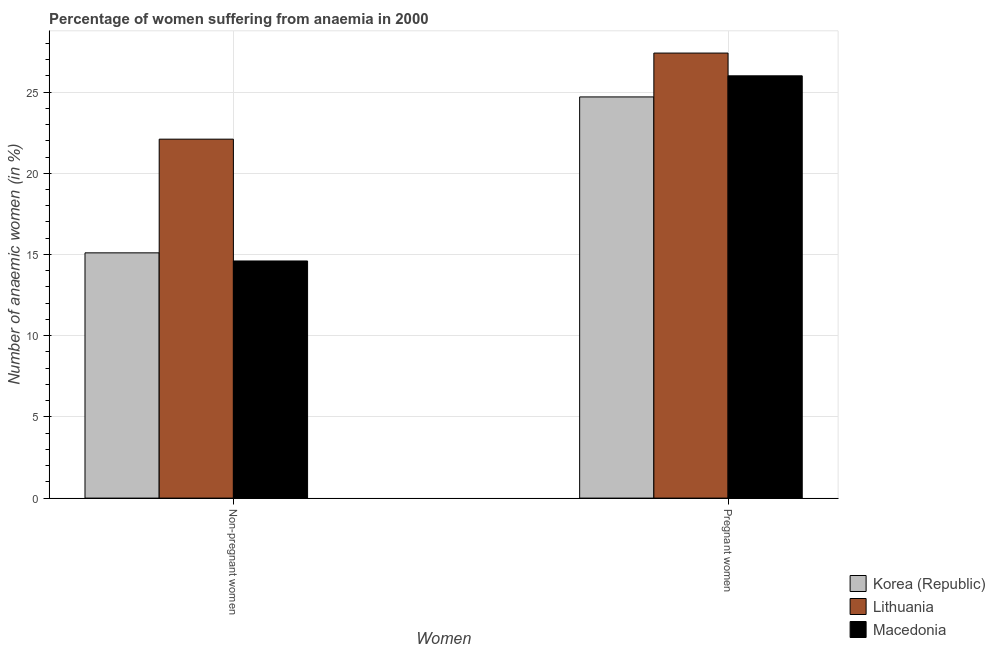How many bars are there on the 1st tick from the left?
Make the answer very short. 3. What is the label of the 1st group of bars from the left?
Provide a succinct answer. Non-pregnant women. What is the percentage of non-pregnant anaemic women in Lithuania?
Ensure brevity in your answer.  22.1. Across all countries, what is the maximum percentage of pregnant anaemic women?
Your response must be concise. 27.4. In which country was the percentage of non-pregnant anaemic women maximum?
Your answer should be very brief. Lithuania. What is the total percentage of pregnant anaemic women in the graph?
Keep it short and to the point. 78.1. What is the difference between the percentage of pregnant anaemic women in Korea (Republic) and that in Macedonia?
Ensure brevity in your answer.  -1.3. What is the difference between the percentage of non-pregnant anaemic women in Lithuania and the percentage of pregnant anaemic women in Korea (Republic)?
Provide a short and direct response. -2.6. What is the average percentage of non-pregnant anaemic women per country?
Keep it short and to the point. 17.27. What is the difference between the percentage of pregnant anaemic women and percentage of non-pregnant anaemic women in Korea (Republic)?
Offer a very short reply. 9.6. What is the ratio of the percentage of pregnant anaemic women in Lithuania to that in Macedonia?
Your answer should be very brief. 1.05. Is the percentage of non-pregnant anaemic women in Lithuania less than that in Macedonia?
Provide a short and direct response. No. What does the 1st bar from the right in Pregnant women represents?
Provide a short and direct response. Macedonia. How many bars are there?
Provide a short and direct response. 6. What is the difference between two consecutive major ticks on the Y-axis?
Your answer should be compact. 5. Are the values on the major ticks of Y-axis written in scientific E-notation?
Offer a very short reply. No. Does the graph contain any zero values?
Make the answer very short. No. Does the graph contain grids?
Keep it short and to the point. Yes. How many legend labels are there?
Provide a short and direct response. 3. What is the title of the graph?
Offer a terse response. Percentage of women suffering from anaemia in 2000. Does "Sub-Saharan Africa (all income levels)" appear as one of the legend labels in the graph?
Offer a very short reply. No. What is the label or title of the X-axis?
Your answer should be compact. Women. What is the label or title of the Y-axis?
Provide a short and direct response. Number of anaemic women (in %). What is the Number of anaemic women (in %) in Lithuania in Non-pregnant women?
Offer a terse response. 22.1. What is the Number of anaemic women (in %) of Macedonia in Non-pregnant women?
Your answer should be very brief. 14.6. What is the Number of anaemic women (in %) in Korea (Republic) in Pregnant women?
Ensure brevity in your answer.  24.7. What is the Number of anaemic women (in %) in Lithuania in Pregnant women?
Offer a very short reply. 27.4. What is the Number of anaemic women (in %) of Macedonia in Pregnant women?
Ensure brevity in your answer.  26. Across all Women, what is the maximum Number of anaemic women (in %) of Korea (Republic)?
Offer a very short reply. 24.7. Across all Women, what is the maximum Number of anaemic women (in %) of Lithuania?
Your answer should be very brief. 27.4. Across all Women, what is the maximum Number of anaemic women (in %) in Macedonia?
Offer a terse response. 26. Across all Women, what is the minimum Number of anaemic women (in %) of Korea (Republic)?
Provide a succinct answer. 15.1. Across all Women, what is the minimum Number of anaemic women (in %) in Lithuania?
Keep it short and to the point. 22.1. Across all Women, what is the minimum Number of anaemic women (in %) of Macedonia?
Your answer should be compact. 14.6. What is the total Number of anaemic women (in %) of Korea (Republic) in the graph?
Your answer should be very brief. 39.8. What is the total Number of anaemic women (in %) of Lithuania in the graph?
Keep it short and to the point. 49.5. What is the total Number of anaemic women (in %) in Macedonia in the graph?
Keep it short and to the point. 40.6. What is the difference between the Number of anaemic women (in %) in Korea (Republic) in Non-pregnant women and that in Pregnant women?
Give a very brief answer. -9.6. What is the difference between the Number of anaemic women (in %) in Macedonia in Non-pregnant women and that in Pregnant women?
Ensure brevity in your answer.  -11.4. What is the difference between the Number of anaemic women (in %) in Korea (Republic) in Non-pregnant women and the Number of anaemic women (in %) in Lithuania in Pregnant women?
Make the answer very short. -12.3. What is the average Number of anaemic women (in %) in Korea (Republic) per Women?
Keep it short and to the point. 19.9. What is the average Number of anaemic women (in %) of Lithuania per Women?
Give a very brief answer. 24.75. What is the average Number of anaemic women (in %) in Macedonia per Women?
Give a very brief answer. 20.3. What is the difference between the Number of anaemic women (in %) of Korea (Republic) and Number of anaemic women (in %) of Lithuania in Non-pregnant women?
Offer a very short reply. -7. What is the difference between the Number of anaemic women (in %) of Korea (Republic) and Number of anaemic women (in %) of Macedonia in Non-pregnant women?
Make the answer very short. 0.5. What is the difference between the Number of anaemic women (in %) of Lithuania and Number of anaemic women (in %) of Macedonia in Non-pregnant women?
Ensure brevity in your answer.  7.5. What is the difference between the Number of anaemic women (in %) of Korea (Republic) and Number of anaemic women (in %) of Lithuania in Pregnant women?
Offer a terse response. -2.7. What is the difference between the Number of anaemic women (in %) in Korea (Republic) and Number of anaemic women (in %) in Macedonia in Pregnant women?
Provide a short and direct response. -1.3. What is the difference between the Number of anaemic women (in %) of Lithuania and Number of anaemic women (in %) of Macedonia in Pregnant women?
Ensure brevity in your answer.  1.4. What is the ratio of the Number of anaemic women (in %) in Korea (Republic) in Non-pregnant women to that in Pregnant women?
Ensure brevity in your answer.  0.61. What is the ratio of the Number of anaemic women (in %) in Lithuania in Non-pregnant women to that in Pregnant women?
Your answer should be very brief. 0.81. What is the ratio of the Number of anaemic women (in %) in Macedonia in Non-pregnant women to that in Pregnant women?
Offer a very short reply. 0.56. What is the difference between the highest and the second highest Number of anaemic women (in %) of Korea (Republic)?
Provide a short and direct response. 9.6. What is the difference between the highest and the second highest Number of anaemic women (in %) of Macedonia?
Keep it short and to the point. 11.4. 